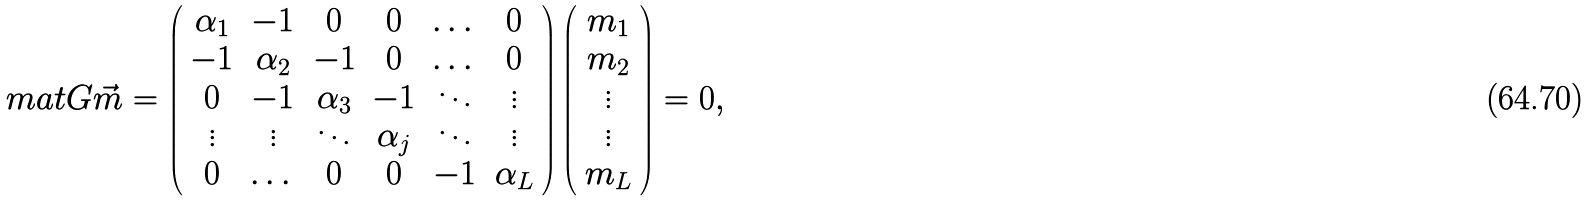<formula> <loc_0><loc_0><loc_500><loc_500>\ m a t { G } \vec { m } = \left ( \begin{array} { c c c c c c } \alpha _ { 1 } & - 1 & 0 & 0 & \dots & 0 \\ - 1 & \alpha _ { 2 } & - 1 & 0 & \dots & 0 \\ 0 & - 1 & \alpha _ { 3 } & - 1 & \ddots & \vdots \\ \vdots & \vdots & \ddots & \alpha _ { j } & \ddots & \vdots \\ 0 & \dots & 0 & 0 & - 1 & \alpha _ { L } \\ \end{array} \right ) \left ( \begin{array} { c } m _ { 1 } \\ m _ { 2 } \\ \vdots \\ \vdots \\ m _ { L } \\ \end{array} \right ) = 0 ,</formula> 